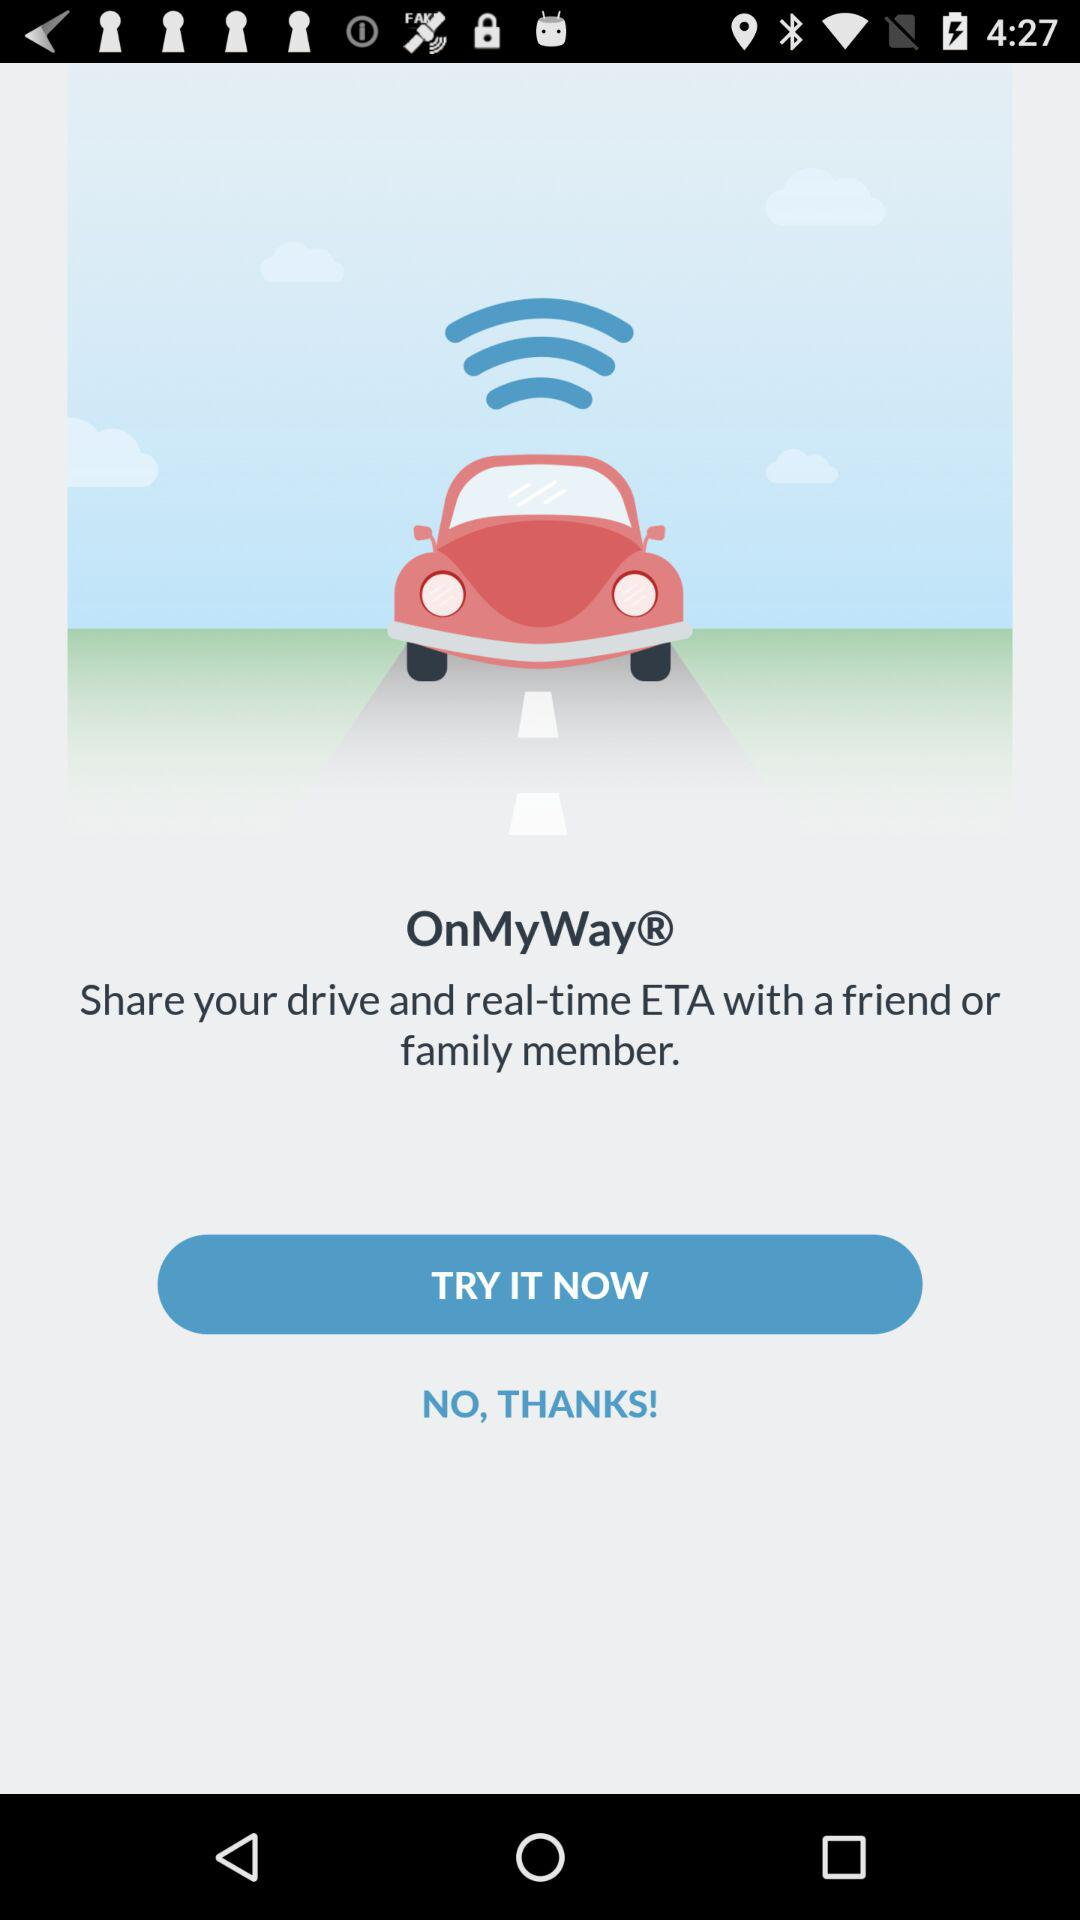What is the name of the application? The name of the application is "OnMyWay". 